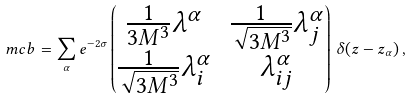Convert formula to latex. <formula><loc_0><loc_0><loc_500><loc_500>\ m c b = \sum _ { \alpha } e ^ { - 2 \sigma } \begin{pmatrix} \frac { 1 } { 3 M ^ { 3 } } \lambda ^ { \alpha } & \frac { 1 } { \sqrt { 3 M ^ { 3 } } } \lambda _ { j } ^ { \alpha } \\ \frac { 1 } { \sqrt { 3 M ^ { 3 } } } \lambda _ { i } ^ { \alpha } & \lambda _ { i j } ^ { \alpha } \end{pmatrix} \, \delta ( z - z _ { \alpha } ) \, ,</formula> 